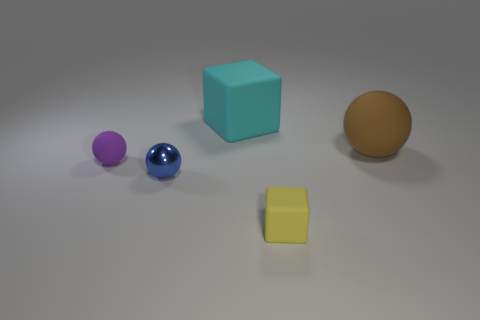Add 4 blue objects. How many objects exist? 9 Subtract all small balls. How many balls are left? 1 Subtract all blue spheres. How many spheres are left? 2 Subtract all blocks. How many objects are left? 3 Subtract all purple matte balls. Subtract all purple objects. How many objects are left? 3 Add 4 large brown things. How many large brown things are left? 5 Add 5 large cyan rubber objects. How many large cyan rubber objects exist? 6 Subtract 0 red cylinders. How many objects are left? 5 Subtract all purple blocks. Subtract all red cylinders. How many blocks are left? 2 Subtract all purple spheres. How many yellow blocks are left? 1 